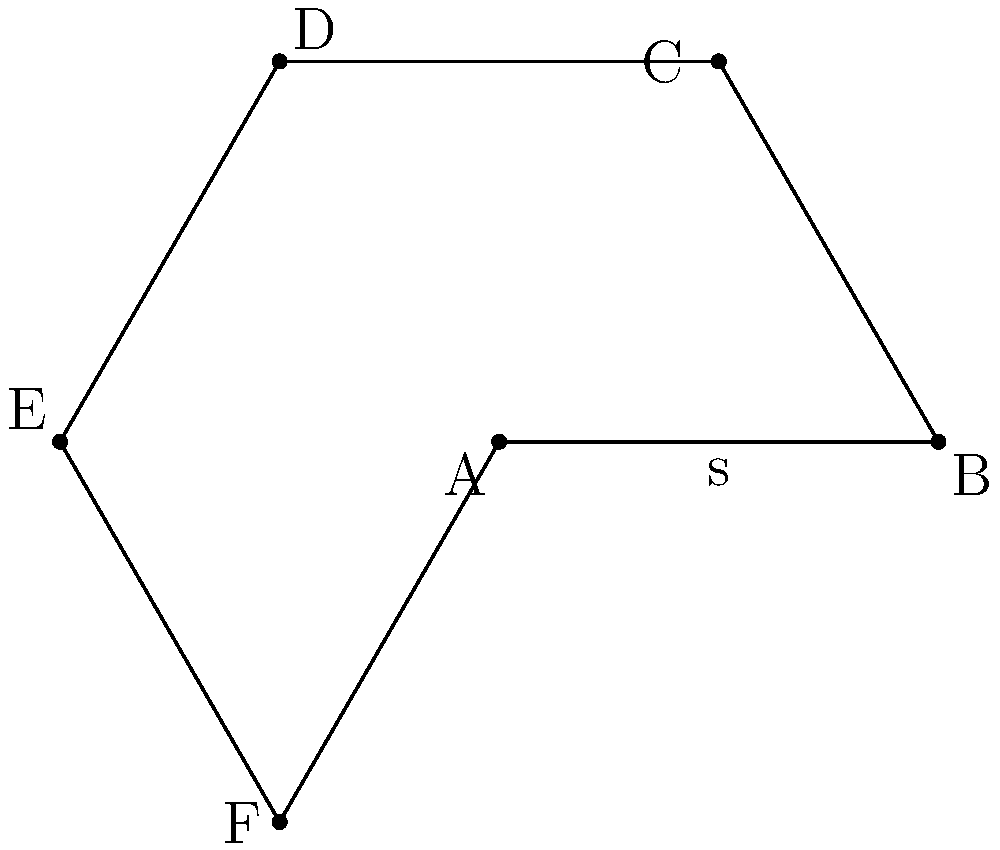In a new energy-efficient building design using bio-compatible materials, a hexagonal solar panel array is proposed. If each side of the hexagonal array measures 10 meters, what is the total area of the array? Round your answer to the nearest square meter. To calculate the area of a regular hexagon, we can use the formula:

$$A = \frac{3\sqrt{3}}{2}s^2$$

Where $s$ is the length of one side.

Step 1: Identify the given information
- Side length (s) = 10 meters

Step 2: Substitute the value into the formula
$$A = \frac{3\sqrt{3}}{2}(10)^2$$

Step 3: Simplify the expression
$$A = \frac{3\sqrt{3}}{2} \cdot 100$$
$$A = 150\sqrt{3}$$

Step 4: Calculate the approximate value
$$A \approx 150 \cdot 1.732050808$$
$$A \approx 259.8076211$$

Step 5: Round to the nearest square meter
$$A \approx 260 \text{ m}^2$$

This calculation is crucial for determining the total surface area of the solar panel array, which directly impacts the energy production capacity and the amount of bio-compatible materials needed for construction.
Answer: 260 m² 